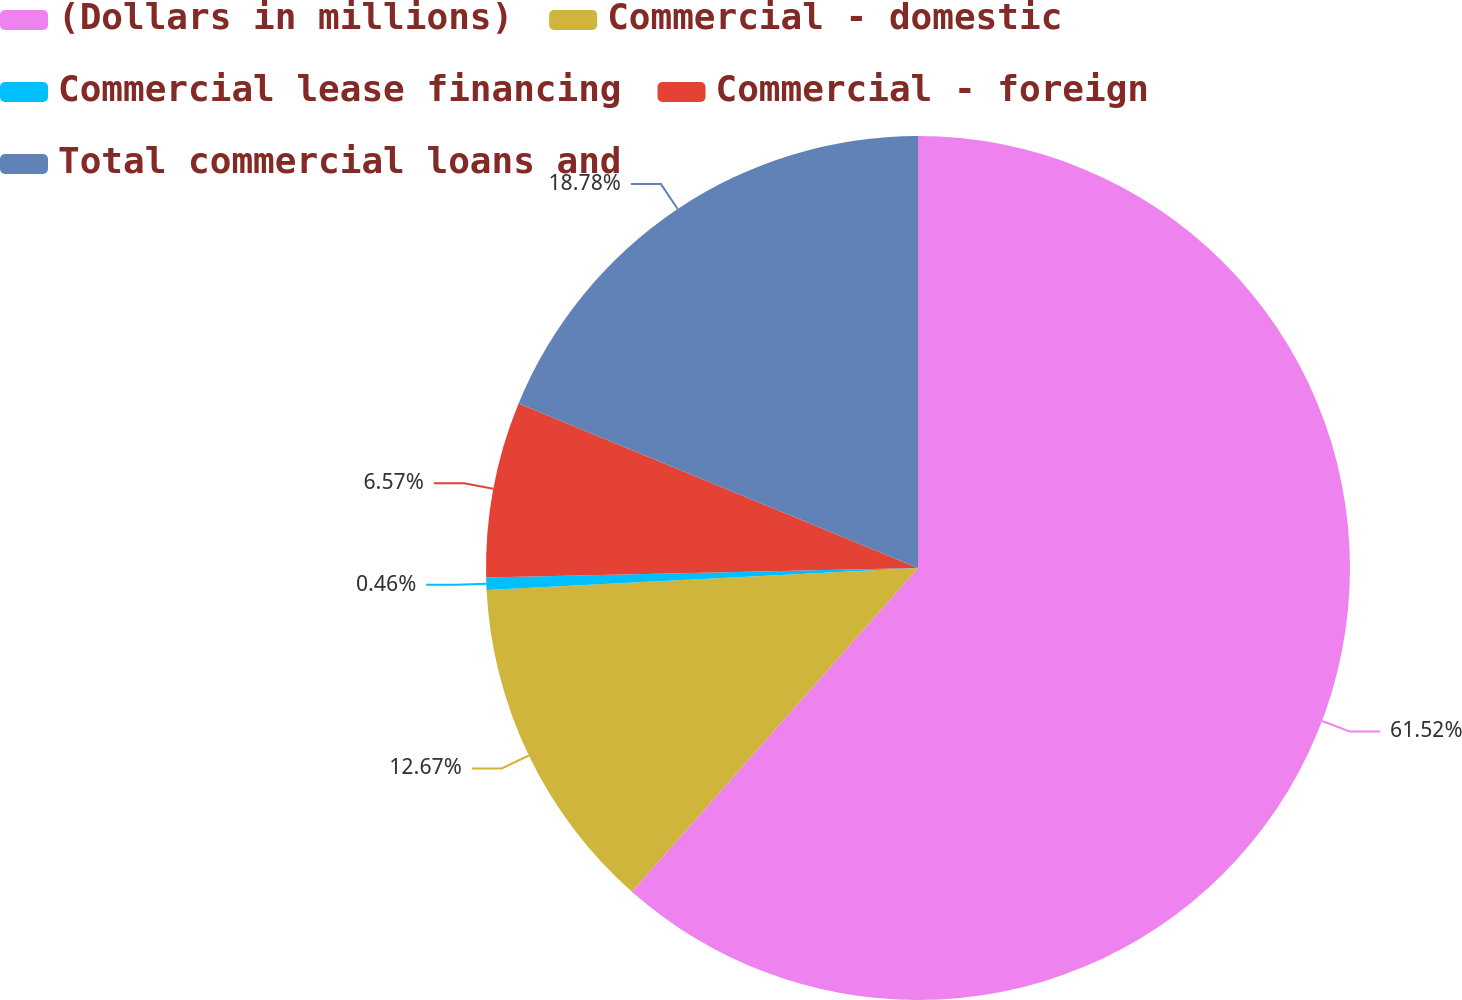<chart> <loc_0><loc_0><loc_500><loc_500><pie_chart><fcel>(Dollars in millions)<fcel>Commercial - domestic<fcel>Commercial lease financing<fcel>Commercial - foreign<fcel>Total commercial loans and<nl><fcel>61.52%<fcel>12.67%<fcel>0.46%<fcel>6.57%<fcel>18.78%<nl></chart> 